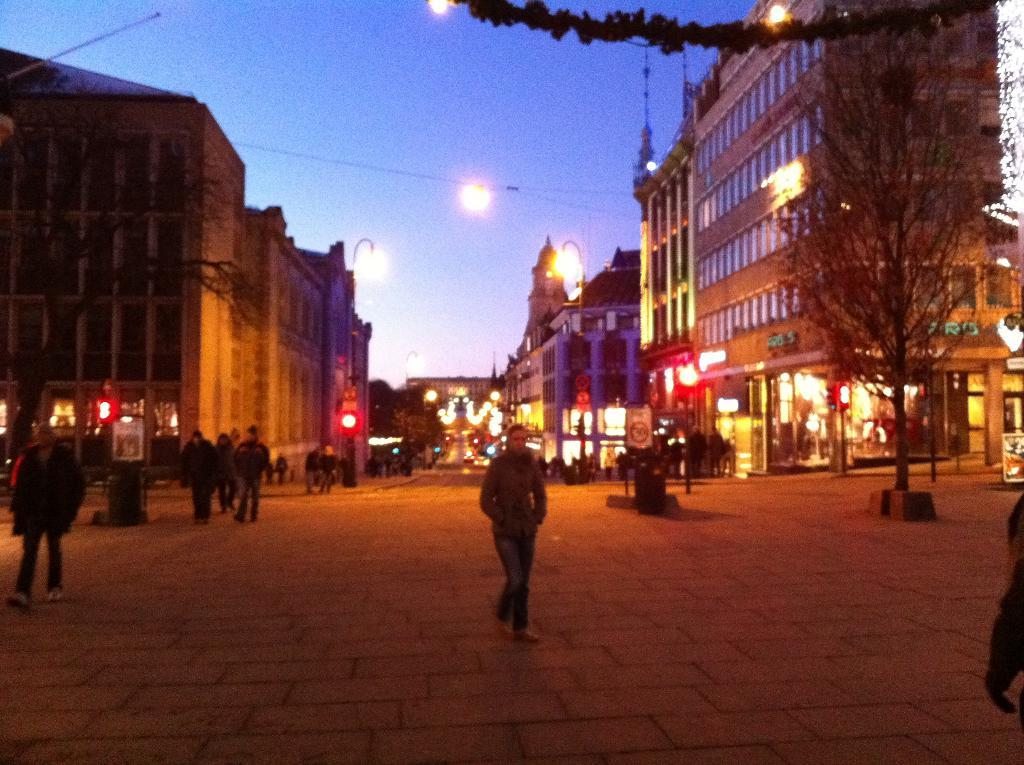What are the people in the image doing? The people in the image are on a path. What else can be seen in the image besides the people? There are boards, lights, buildings, and other objects in the image. What is the condition of the sky in the image? The sky is visible in the image. What type of neck can be seen on the ducks in the image? There are no ducks or necks present in the image. 